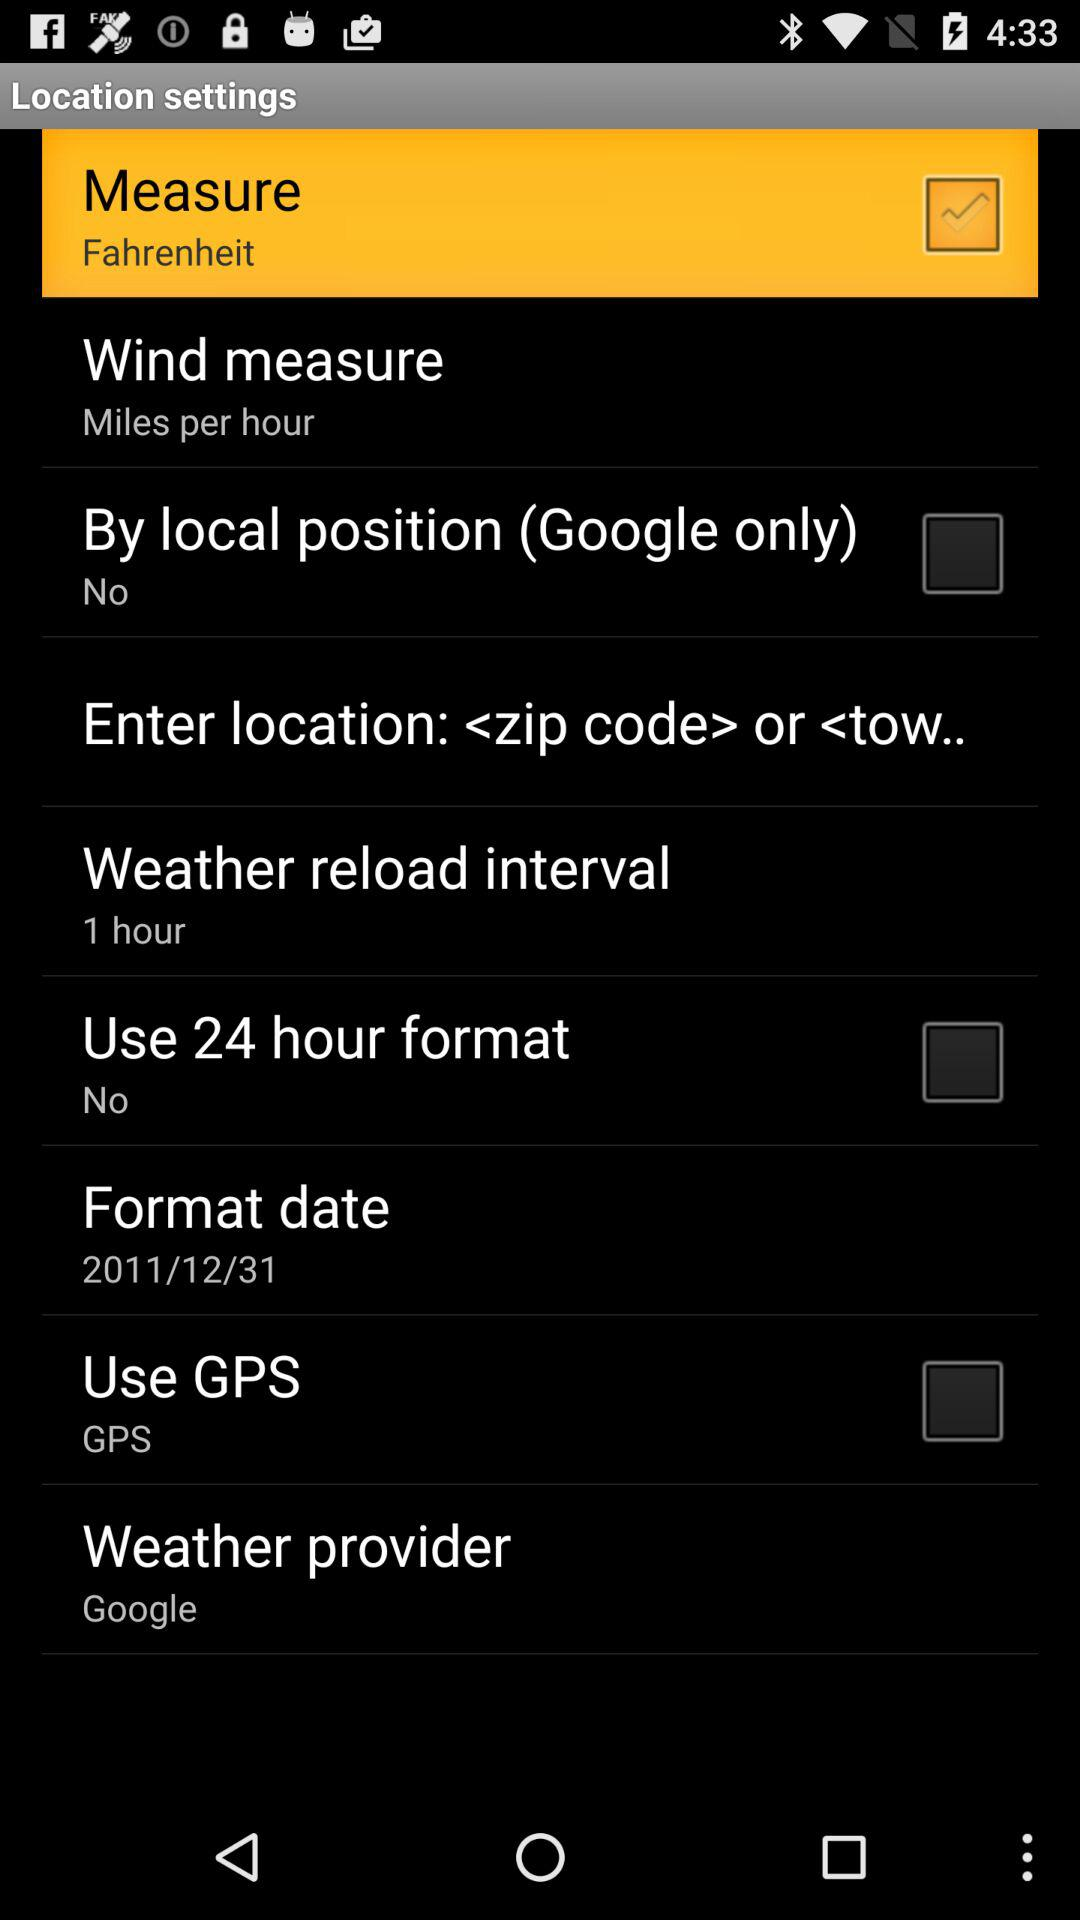What is the format of the date? The format of the date is 2011/12/31. 